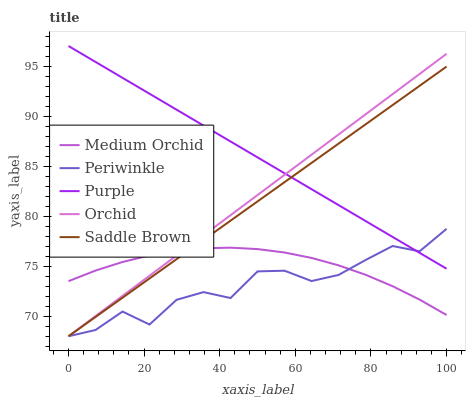Does Periwinkle have the minimum area under the curve?
Answer yes or no. Yes. Does Purple have the maximum area under the curve?
Answer yes or no. Yes. Does Medium Orchid have the minimum area under the curve?
Answer yes or no. No. Does Medium Orchid have the maximum area under the curve?
Answer yes or no. No. Is Orchid the smoothest?
Answer yes or no. Yes. Is Periwinkle the roughest?
Answer yes or no. Yes. Is Medium Orchid the smoothest?
Answer yes or no. No. Is Medium Orchid the roughest?
Answer yes or no. No. Does Periwinkle have the lowest value?
Answer yes or no. Yes. Does Medium Orchid have the lowest value?
Answer yes or no. No. Does Purple have the highest value?
Answer yes or no. Yes. Does Periwinkle have the highest value?
Answer yes or no. No. Is Medium Orchid less than Purple?
Answer yes or no. Yes. Is Purple greater than Medium Orchid?
Answer yes or no. Yes. Does Saddle Brown intersect Periwinkle?
Answer yes or no. Yes. Is Saddle Brown less than Periwinkle?
Answer yes or no. No. Is Saddle Brown greater than Periwinkle?
Answer yes or no. No. Does Medium Orchid intersect Purple?
Answer yes or no. No. 